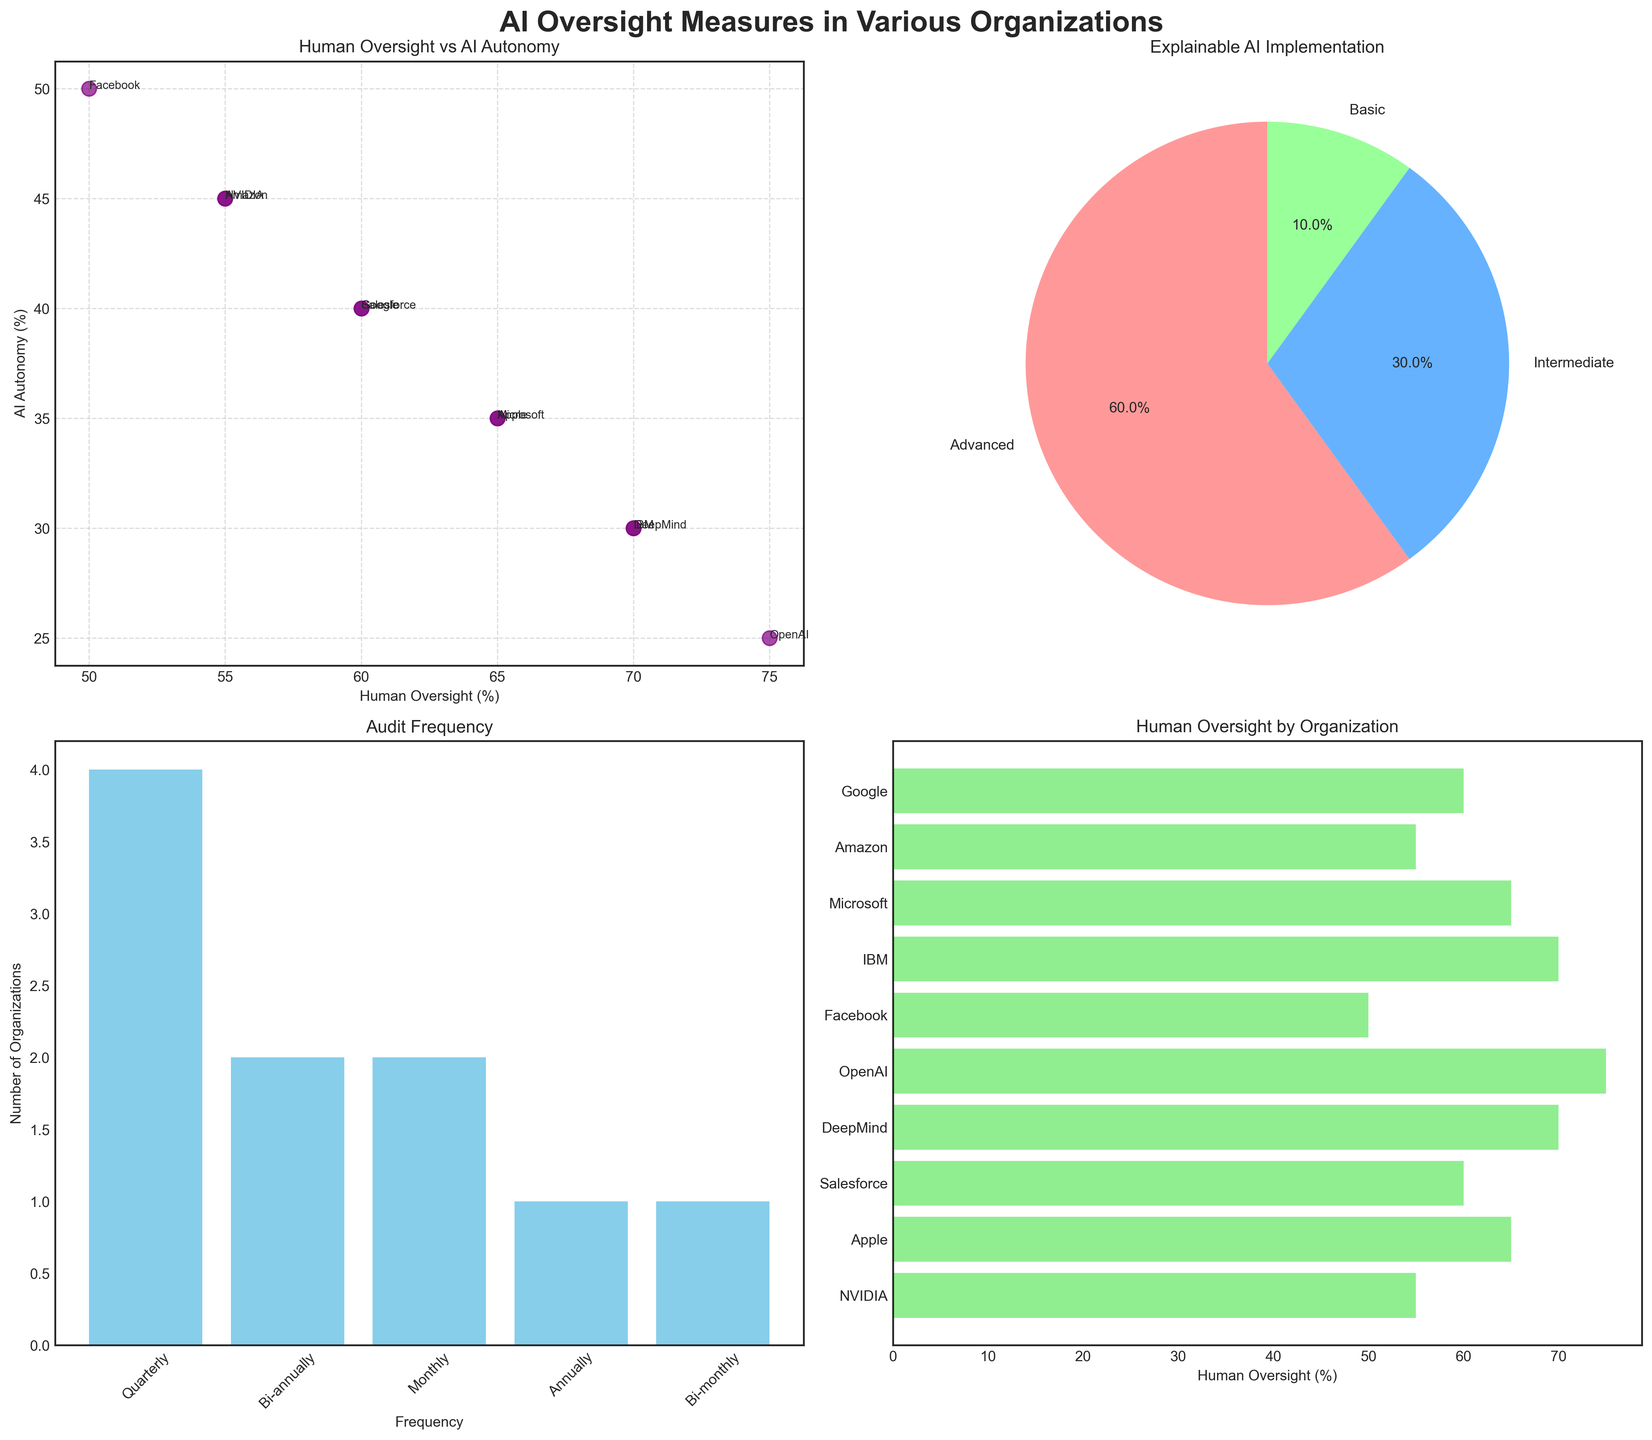What is the overall trend in the percentage of Human Oversight vs AI Autonomy among the organizations? By examining the scatter plot titled "Human Oversight vs AI Autonomy," we observe that most organizations have higher Human Oversight percentages compared to AI Autonomy. Organizations like OpenAI, IBM, and Microsoft show a Human Oversight percentage significantly higher than their AI Autonomy percentage.
Answer: Higher Human Oversight Which organization has the highest percentage of Human Oversight? The horizontal bar chart in the bottom right titled "Human Oversight by Organization" indicates that OpenAI has the highest Human Oversight percentage, at 75%.
Answer: OpenAI What is the most common Audit Frequency among the organizations? The bar chart in the bottom left titled "Audit Frequency" shows that "Quarterly" is the most common audit frequency among the organizations.
Answer: Quarterly What percentage of organizations implement Advanced Explainable AI? The pie chart in the top right titled "Explainable AI Implementation" shows that the slice labeled "Advanced" comprises 50% of the total.
Answer: 50% How many organizations conduct audits on a bi-annual basis? Referring to the "Audit Frequency" bar chart, we see two organizations conduct audits bi-annually.
Answer: Two How does Facebook's Human Oversight percentage compare to NVIDIA's? By looking at the scatter plot in the top left, we can see that Facebook and NVIDIA both have approximately the same Human Oversight percentage, around 50-55%.
Answer: Nearly the same What is the difference in Human Oversight percentage between Google and Apple? From both the scatter plot and the horizontal bar chart, Google has 60% and Apple has 65%, resulting in a difference of 5%.
Answer: 5% Do more organizations implement Advanced Explainable AI or Intermediate Explainable AI? The pie chart shows a larger slice for "Advanced" compared to "Intermediate," indicating more organizations implement Advanced Explainable AI.
Answer: Advanced Which organizations conduct their audits more frequently than quarterly? The horizontal bar chart under "Audit Frequency" shows that Microsoft (Monthly) and OpenAI (Monthly) conduct audits more frequently than quarterly.
Answer: Microsoft and OpenAI 